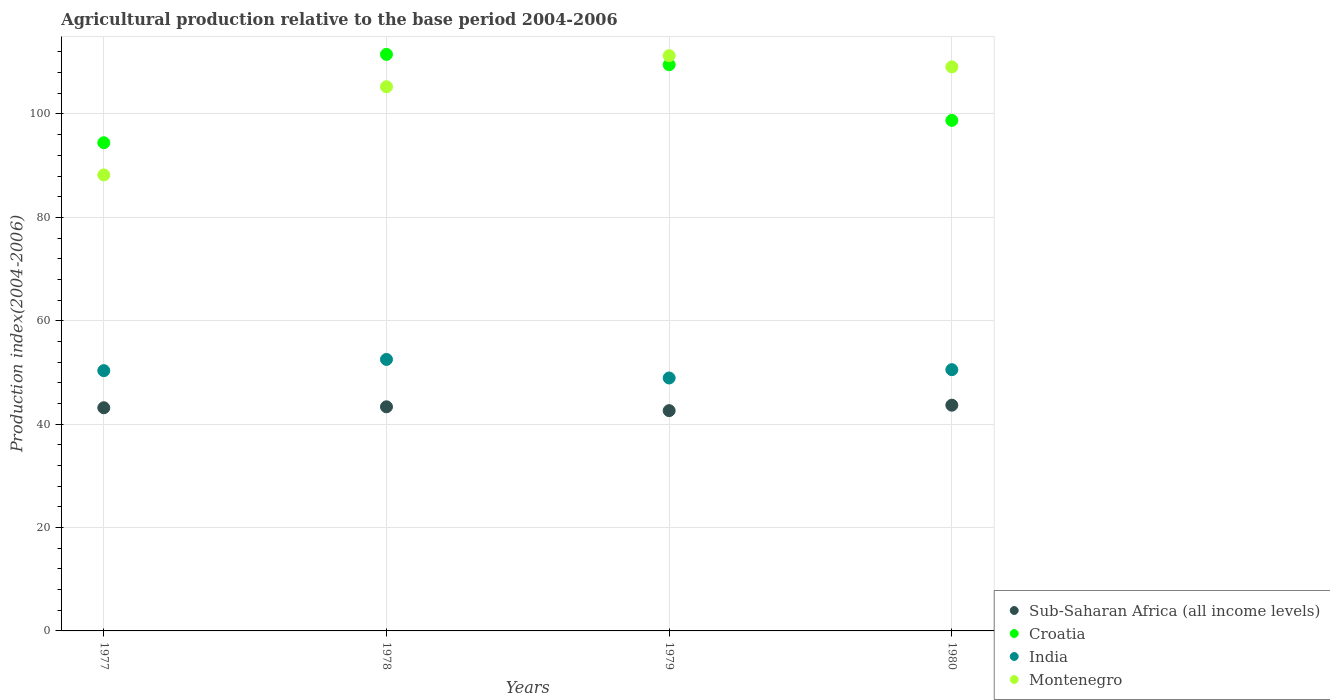How many different coloured dotlines are there?
Your answer should be compact. 4. Is the number of dotlines equal to the number of legend labels?
Provide a succinct answer. Yes. What is the agricultural production index in Sub-Saharan Africa (all income levels) in 1980?
Your response must be concise. 43.67. Across all years, what is the maximum agricultural production index in Croatia?
Offer a very short reply. 111.53. Across all years, what is the minimum agricultural production index in Montenegro?
Provide a short and direct response. 88.21. In which year was the agricultural production index in Montenegro maximum?
Your response must be concise. 1979. In which year was the agricultural production index in Montenegro minimum?
Your answer should be compact. 1977. What is the total agricultural production index in Sub-Saharan Africa (all income levels) in the graph?
Your response must be concise. 172.81. What is the difference between the agricultural production index in India in 1977 and that in 1979?
Keep it short and to the point. 1.42. What is the difference between the agricultural production index in India in 1979 and the agricultural production index in Sub-Saharan Africa (all income levels) in 1977?
Give a very brief answer. 5.76. What is the average agricultural production index in India per year?
Ensure brevity in your answer.  50.59. In the year 1978, what is the difference between the agricultural production index in Croatia and agricultural production index in India?
Offer a very short reply. 59.01. In how many years, is the agricultural production index in Sub-Saharan Africa (all income levels) greater than 48?
Provide a succinct answer. 0. What is the ratio of the agricultural production index in Montenegro in 1978 to that in 1980?
Your response must be concise. 0.96. What is the difference between the highest and the second highest agricultural production index in India?
Give a very brief answer. 1.98. What is the difference between the highest and the lowest agricultural production index in Montenegro?
Your answer should be compact. 23.07. Is it the case that in every year, the sum of the agricultural production index in Sub-Saharan Africa (all income levels) and agricultural production index in Croatia  is greater than the agricultural production index in India?
Provide a succinct answer. Yes. Is the agricultural production index in Montenegro strictly greater than the agricultural production index in India over the years?
Your response must be concise. Yes. How many dotlines are there?
Provide a succinct answer. 4. How many years are there in the graph?
Provide a succinct answer. 4. What is the difference between two consecutive major ticks on the Y-axis?
Your answer should be compact. 20. Where does the legend appear in the graph?
Provide a succinct answer. Bottom right. What is the title of the graph?
Provide a short and direct response. Agricultural production relative to the base period 2004-2006. What is the label or title of the X-axis?
Provide a succinct answer. Years. What is the label or title of the Y-axis?
Your answer should be compact. Production index(2004-2006). What is the Production index(2004-2006) of Sub-Saharan Africa (all income levels) in 1977?
Keep it short and to the point. 43.17. What is the Production index(2004-2006) of Croatia in 1977?
Ensure brevity in your answer.  94.44. What is the Production index(2004-2006) of India in 1977?
Offer a terse response. 50.35. What is the Production index(2004-2006) of Montenegro in 1977?
Offer a very short reply. 88.21. What is the Production index(2004-2006) of Sub-Saharan Africa (all income levels) in 1978?
Provide a short and direct response. 43.36. What is the Production index(2004-2006) of Croatia in 1978?
Keep it short and to the point. 111.53. What is the Production index(2004-2006) in India in 1978?
Provide a short and direct response. 52.52. What is the Production index(2004-2006) in Montenegro in 1978?
Your answer should be compact. 105.27. What is the Production index(2004-2006) of Sub-Saharan Africa (all income levels) in 1979?
Ensure brevity in your answer.  42.61. What is the Production index(2004-2006) of Croatia in 1979?
Keep it short and to the point. 109.53. What is the Production index(2004-2006) of India in 1979?
Provide a succinct answer. 48.93. What is the Production index(2004-2006) in Montenegro in 1979?
Your response must be concise. 111.28. What is the Production index(2004-2006) of Sub-Saharan Africa (all income levels) in 1980?
Ensure brevity in your answer.  43.67. What is the Production index(2004-2006) in Croatia in 1980?
Offer a terse response. 98.76. What is the Production index(2004-2006) of India in 1980?
Make the answer very short. 50.54. What is the Production index(2004-2006) in Montenegro in 1980?
Your response must be concise. 109.11. Across all years, what is the maximum Production index(2004-2006) of Sub-Saharan Africa (all income levels)?
Make the answer very short. 43.67. Across all years, what is the maximum Production index(2004-2006) of Croatia?
Give a very brief answer. 111.53. Across all years, what is the maximum Production index(2004-2006) in India?
Ensure brevity in your answer.  52.52. Across all years, what is the maximum Production index(2004-2006) of Montenegro?
Ensure brevity in your answer.  111.28. Across all years, what is the minimum Production index(2004-2006) of Sub-Saharan Africa (all income levels)?
Give a very brief answer. 42.61. Across all years, what is the minimum Production index(2004-2006) of Croatia?
Keep it short and to the point. 94.44. Across all years, what is the minimum Production index(2004-2006) of India?
Provide a succinct answer. 48.93. Across all years, what is the minimum Production index(2004-2006) of Montenegro?
Your response must be concise. 88.21. What is the total Production index(2004-2006) of Sub-Saharan Africa (all income levels) in the graph?
Your answer should be very brief. 172.81. What is the total Production index(2004-2006) in Croatia in the graph?
Keep it short and to the point. 414.26. What is the total Production index(2004-2006) in India in the graph?
Offer a very short reply. 202.34. What is the total Production index(2004-2006) of Montenegro in the graph?
Offer a terse response. 413.87. What is the difference between the Production index(2004-2006) in Sub-Saharan Africa (all income levels) in 1977 and that in 1978?
Offer a terse response. -0.18. What is the difference between the Production index(2004-2006) of Croatia in 1977 and that in 1978?
Ensure brevity in your answer.  -17.09. What is the difference between the Production index(2004-2006) in India in 1977 and that in 1978?
Offer a very short reply. -2.17. What is the difference between the Production index(2004-2006) of Montenegro in 1977 and that in 1978?
Provide a succinct answer. -17.06. What is the difference between the Production index(2004-2006) of Sub-Saharan Africa (all income levels) in 1977 and that in 1979?
Keep it short and to the point. 0.56. What is the difference between the Production index(2004-2006) in Croatia in 1977 and that in 1979?
Provide a short and direct response. -15.09. What is the difference between the Production index(2004-2006) in India in 1977 and that in 1979?
Your response must be concise. 1.42. What is the difference between the Production index(2004-2006) in Montenegro in 1977 and that in 1979?
Provide a short and direct response. -23.07. What is the difference between the Production index(2004-2006) in Sub-Saharan Africa (all income levels) in 1977 and that in 1980?
Your response must be concise. -0.49. What is the difference between the Production index(2004-2006) of Croatia in 1977 and that in 1980?
Your answer should be compact. -4.32. What is the difference between the Production index(2004-2006) of India in 1977 and that in 1980?
Provide a short and direct response. -0.19. What is the difference between the Production index(2004-2006) of Montenegro in 1977 and that in 1980?
Keep it short and to the point. -20.9. What is the difference between the Production index(2004-2006) of Sub-Saharan Africa (all income levels) in 1978 and that in 1979?
Your answer should be compact. 0.74. What is the difference between the Production index(2004-2006) in Croatia in 1978 and that in 1979?
Provide a short and direct response. 2. What is the difference between the Production index(2004-2006) in India in 1978 and that in 1979?
Give a very brief answer. 3.59. What is the difference between the Production index(2004-2006) of Montenegro in 1978 and that in 1979?
Offer a terse response. -6.01. What is the difference between the Production index(2004-2006) of Sub-Saharan Africa (all income levels) in 1978 and that in 1980?
Keep it short and to the point. -0.31. What is the difference between the Production index(2004-2006) of Croatia in 1978 and that in 1980?
Provide a short and direct response. 12.77. What is the difference between the Production index(2004-2006) in India in 1978 and that in 1980?
Your answer should be very brief. 1.98. What is the difference between the Production index(2004-2006) of Montenegro in 1978 and that in 1980?
Offer a terse response. -3.84. What is the difference between the Production index(2004-2006) in Sub-Saharan Africa (all income levels) in 1979 and that in 1980?
Keep it short and to the point. -1.05. What is the difference between the Production index(2004-2006) in Croatia in 1979 and that in 1980?
Keep it short and to the point. 10.77. What is the difference between the Production index(2004-2006) of India in 1979 and that in 1980?
Offer a terse response. -1.61. What is the difference between the Production index(2004-2006) in Montenegro in 1979 and that in 1980?
Give a very brief answer. 2.17. What is the difference between the Production index(2004-2006) in Sub-Saharan Africa (all income levels) in 1977 and the Production index(2004-2006) in Croatia in 1978?
Your response must be concise. -68.36. What is the difference between the Production index(2004-2006) in Sub-Saharan Africa (all income levels) in 1977 and the Production index(2004-2006) in India in 1978?
Ensure brevity in your answer.  -9.35. What is the difference between the Production index(2004-2006) in Sub-Saharan Africa (all income levels) in 1977 and the Production index(2004-2006) in Montenegro in 1978?
Your answer should be very brief. -62.1. What is the difference between the Production index(2004-2006) of Croatia in 1977 and the Production index(2004-2006) of India in 1978?
Offer a very short reply. 41.92. What is the difference between the Production index(2004-2006) of Croatia in 1977 and the Production index(2004-2006) of Montenegro in 1978?
Make the answer very short. -10.83. What is the difference between the Production index(2004-2006) of India in 1977 and the Production index(2004-2006) of Montenegro in 1978?
Offer a very short reply. -54.92. What is the difference between the Production index(2004-2006) in Sub-Saharan Africa (all income levels) in 1977 and the Production index(2004-2006) in Croatia in 1979?
Your answer should be very brief. -66.36. What is the difference between the Production index(2004-2006) of Sub-Saharan Africa (all income levels) in 1977 and the Production index(2004-2006) of India in 1979?
Provide a short and direct response. -5.76. What is the difference between the Production index(2004-2006) in Sub-Saharan Africa (all income levels) in 1977 and the Production index(2004-2006) in Montenegro in 1979?
Ensure brevity in your answer.  -68.11. What is the difference between the Production index(2004-2006) of Croatia in 1977 and the Production index(2004-2006) of India in 1979?
Provide a short and direct response. 45.51. What is the difference between the Production index(2004-2006) of Croatia in 1977 and the Production index(2004-2006) of Montenegro in 1979?
Your response must be concise. -16.84. What is the difference between the Production index(2004-2006) in India in 1977 and the Production index(2004-2006) in Montenegro in 1979?
Provide a succinct answer. -60.93. What is the difference between the Production index(2004-2006) in Sub-Saharan Africa (all income levels) in 1977 and the Production index(2004-2006) in Croatia in 1980?
Your answer should be very brief. -55.59. What is the difference between the Production index(2004-2006) in Sub-Saharan Africa (all income levels) in 1977 and the Production index(2004-2006) in India in 1980?
Keep it short and to the point. -7.37. What is the difference between the Production index(2004-2006) of Sub-Saharan Africa (all income levels) in 1977 and the Production index(2004-2006) of Montenegro in 1980?
Provide a succinct answer. -65.94. What is the difference between the Production index(2004-2006) in Croatia in 1977 and the Production index(2004-2006) in India in 1980?
Provide a short and direct response. 43.9. What is the difference between the Production index(2004-2006) of Croatia in 1977 and the Production index(2004-2006) of Montenegro in 1980?
Keep it short and to the point. -14.67. What is the difference between the Production index(2004-2006) in India in 1977 and the Production index(2004-2006) in Montenegro in 1980?
Your response must be concise. -58.76. What is the difference between the Production index(2004-2006) of Sub-Saharan Africa (all income levels) in 1978 and the Production index(2004-2006) of Croatia in 1979?
Provide a succinct answer. -66.17. What is the difference between the Production index(2004-2006) in Sub-Saharan Africa (all income levels) in 1978 and the Production index(2004-2006) in India in 1979?
Keep it short and to the point. -5.57. What is the difference between the Production index(2004-2006) of Sub-Saharan Africa (all income levels) in 1978 and the Production index(2004-2006) of Montenegro in 1979?
Make the answer very short. -67.92. What is the difference between the Production index(2004-2006) in Croatia in 1978 and the Production index(2004-2006) in India in 1979?
Provide a succinct answer. 62.6. What is the difference between the Production index(2004-2006) in Croatia in 1978 and the Production index(2004-2006) in Montenegro in 1979?
Your response must be concise. 0.25. What is the difference between the Production index(2004-2006) in India in 1978 and the Production index(2004-2006) in Montenegro in 1979?
Keep it short and to the point. -58.76. What is the difference between the Production index(2004-2006) of Sub-Saharan Africa (all income levels) in 1978 and the Production index(2004-2006) of Croatia in 1980?
Give a very brief answer. -55.4. What is the difference between the Production index(2004-2006) of Sub-Saharan Africa (all income levels) in 1978 and the Production index(2004-2006) of India in 1980?
Ensure brevity in your answer.  -7.18. What is the difference between the Production index(2004-2006) in Sub-Saharan Africa (all income levels) in 1978 and the Production index(2004-2006) in Montenegro in 1980?
Your answer should be very brief. -65.75. What is the difference between the Production index(2004-2006) in Croatia in 1978 and the Production index(2004-2006) in India in 1980?
Give a very brief answer. 60.99. What is the difference between the Production index(2004-2006) in Croatia in 1978 and the Production index(2004-2006) in Montenegro in 1980?
Your answer should be very brief. 2.42. What is the difference between the Production index(2004-2006) in India in 1978 and the Production index(2004-2006) in Montenegro in 1980?
Your response must be concise. -56.59. What is the difference between the Production index(2004-2006) of Sub-Saharan Africa (all income levels) in 1979 and the Production index(2004-2006) of Croatia in 1980?
Offer a very short reply. -56.15. What is the difference between the Production index(2004-2006) in Sub-Saharan Africa (all income levels) in 1979 and the Production index(2004-2006) in India in 1980?
Give a very brief answer. -7.93. What is the difference between the Production index(2004-2006) in Sub-Saharan Africa (all income levels) in 1979 and the Production index(2004-2006) in Montenegro in 1980?
Your answer should be compact. -66.5. What is the difference between the Production index(2004-2006) of Croatia in 1979 and the Production index(2004-2006) of India in 1980?
Your answer should be compact. 58.99. What is the difference between the Production index(2004-2006) in Croatia in 1979 and the Production index(2004-2006) in Montenegro in 1980?
Give a very brief answer. 0.42. What is the difference between the Production index(2004-2006) of India in 1979 and the Production index(2004-2006) of Montenegro in 1980?
Ensure brevity in your answer.  -60.18. What is the average Production index(2004-2006) in Sub-Saharan Africa (all income levels) per year?
Make the answer very short. 43.2. What is the average Production index(2004-2006) in Croatia per year?
Your answer should be compact. 103.56. What is the average Production index(2004-2006) of India per year?
Your response must be concise. 50.59. What is the average Production index(2004-2006) of Montenegro per year?
Your answer should be compact. 103.47. In the year 1977, what is the difference between the Production index(2004-2006) in Sub-Saharan Africa (all income levels) and Production index(2004-2006) in Croatia?
Make the answer very short. -51.27. In the year 1977, what is the difference between the Production index(2004-2006) of Sub-Saharan Africa (all income levels) and Production index(2004-2006) of India?
Your answer should be compact. -7.18. In the year 1977, what is the difference between the Production index(2004-2006) of Sub-Saharan Africa (all income levels) and Production index(2004-2006) of Montenegro?
Offer a terse response. -45.04. In the year 1977, what is the difference between the Production index(2004-2006) of Croatia and Production index(2004-2006) of India?
Provide a succinct answer. 44.09. In the year 1977, what is the difference between the Production index(2004-2006) of Croatia and Production index(2004-2006) of Montenegro?
Your answer should be very brief. 6.23. In the year 1977, what is the difference between the Production index(2004-2006) of India and Production index(2004-2006) of Montenegro?
Your answer should be compact. -37.86. In the year 1978, what is the difference between the Production index(2004-2006) in Sub-Saharan Africa (all income levels) and Production index(2004-2006) in Croatia?
Offer a very short reply. -68.17. In the year 1978, what is the difference between the Production index(2004-2006) in Sub-Saharan Africa (all income levels) and Production index(2004-2006) in India?
Give a very brief answer. -9.16. In the year 1978, what is the difference between the Production index(2004-2006) in Sub-Saharan Africa (all income levels) and Production index(2004-2006) in Montenegro?
Ensure brevity in your answer.  -61.91. In the year 1978, what is the difference between the Production index(2004-2006) in Croatia and Production index(2004-2006) in India?
Keep it short and to the point. 59.01. In the year 1978, what is the difference between the Production index(2004-2006) in Croatia and Production index(2004-2006) in Montenegro?
Your answer should be very brief. 6.26. In the year 1978, what is the difference between the Production index(2004-2006) in India and Production index(2004-2006) in Montenegro?
Offer a terse response. -52.75. In the year 1979, what is the difference between the Production index(2004-2006) in Sub-Saharan Africa (all income levels) and Production index(2004-2006) in Croatia?
Provide a short and direct response. -66.92. In the year 1979, what is the difference between the Production index(2004-2006) in Sub-Saharan Africa (all income levels) and Production index(2004-2006) in India?
Provide a succinct answer. -6.32. In the year 1979, what is the difference between the Production index(2004-2006) in Sub-Saharan Africa (all income levels) and Production index(2004-2006) in Montenegro?
Offer a very short reply. -68.67. In the year 1979, what is the difference between the Production index(2004-2006) in Croatia and Production index(2004-2006) in India?
Offer a very short reply. 60.6. In the year 1979, what is the difference between the Production index(2004-2006) of Croatia and Production index(2004-2006) of Montenegro?
Ensure brevity in your answer.  -1.75. In the year 1979, what is the difference between the Production index(2004-2006) of India and Production index(2004-2006) of Montenegro?
Provide a succinct answer. -62.35. In the year 1980, what is the difference between the Production index(2004-2006) in Sub-Saharan Africa (all income levels) and Production index(2004-2006) in Croatia?
Offer a terse response. -55.09. In the year 1980, what is the difference between the Production index(2004-2006) in Sub-Saharan Africa (all income levels) and Production index(2004-2006) in India?
Offer a very short reply. -6.87. In the year 1980, what is the difference between the Production index(2004-2006) in Sub-Saharan Africa (all income levels) and Production index(2004-2006) in Montenegro?
Offer a terse response. -65.44. In the year 1980, what is the difference between the Production index(2004-2006) of Croatia and Production index(2004-2006) of India?
Make the answer very short. 48.22. In the year 1980, what is the difference between the Production index(2004-2006) in Croatia and Production index(2004-2006) in Montenegro?
Give a very brief answer. -10.35. In the year 1980, what is the difference between the Production index(2004-2006) in India and Production index(2004-2006) in Montenegro?
Provide a succinct answer. -58.57. What is the ratio of the Production index(2004-2006) of Sub-Saharan Africa (all income levels) in 1977 to that in 1978?
Ensure brevity in your answer.  1. What is the ratio of the Production index(2004-2006) of Croatia in 1977 to that in 1978?
Keep it short and to the point. 0.85. What is the ratio of the Production index(2004-2006) of India in 1977 to that in 1978?
Offer a very short reply. 0.96. What is the ratio of the Production index(2004-2006) of Montenegro in 1977 to that in 1978?
Make the answer very short. 0.84. What is the ratio of the Production index(2004-2006) in Sub-Saharan Africa (all income levels) in 1977 to that in 1979?
Make the answer very short. 1.01. What is the ratio of the Production index(2004-2006) in Croatia in 1977 to that in 1979?
Give a very brief answer. 0.86. What is the ratio of the Production index(2004-2006) in India in 1977 to that in 1979?
Give a very brief answer. 1.03. What is the ratio of the Production index(2004-2006) of Montenegro in 1977 to that in 1979?
Your answer should be very brief. 0.79. What is the ratio of the Production index(2004-2006) of Sub-Saharan Africa (all income levels) in 1977 to that in 1980?
Give a very brief answer. 0.99. What is the ratio of the Production index(2004-2006) of Croatia in 1977 to that in 1980?
Your response must be concise. 0.96. What is the ratio of the Production index(2004-2006) in Montenegro in 1977 to that in 1980?
Provide a succinct answer. 0.81. What is the ratio of the Production index(2004-2006) in Sub-Saharan Africa (all income levels) in 1978 to that in 1979?
Provide a succinct answer. 1.02. What is the ratio of the Production index(2004-2006) in Croatia in 1978 to that in 1979?
Offer a very short reply. 1.02. What is the ratio of the Production index(2004-2006) in India in 1978 to that in 1979?
Offer a very short reply. 1.07. What is the ratio of the Production index(2004-2006) in Montenegro in 1978 to that in 1979?
Ensure brevity in your answer.  0.95. What is the ratio of the Production index(2004-2006) of Sub-Saharan Africa (all income levels) in 1978 to that in 1980?
Offer a terse response. 0.99. What is the ratio of the Production index(2004-2006) in Croatia in 1978 to that in 1980?
Your answer should be compact. 1.13. What is the ratio of the Production index(2004-2006) of India in 1978 to that in 1980?
Your answer should be compact. 1.04. What is the ratio of the Production index(2004-2006) of Montenegro in 1978 to that in 1980?
Your response must be concise. 0.96. What is the ratio of the Production index(2004-2006) in Sub-Saharan Africa (all income levels) in 1979 to that in 1980?
Your answer should be compact. 0.98. What is the ratio of the Production index(2004-2006) in Croatia in 1979 to that in 1980?
Your answer should be very brief. 1.11. What is the ratio of the Production index(2004-2006) of India in 1979 to that in 1980?
Offer a terse response. 0.97. What is the ratio of the Production index(2004-2006) of Montenegro in 1979 to that in 1980?
Ensure brevity in your answer.  1.02. What is the difference between the highest and the second highest Production index(2004-2006) in Sub-Saharan Africa (all income levels)?
Provide a succinct answer. 0.31. What is the difference between the highest and the second highest Production index(2004-2006) of Croatia?
Offer a very short reply. 2. What is the difference between the highest and the second highest Production index(2004-2006) of India?
Provide a short and direct response. 1.98. What is the difference between the highest and the second highest Production index(2004-2006) of Montenegro?
Provide a short and direct response. 2.17. What is the difference between the highest and the lowest Production index(2004-2006) in Sub-Saharan Africa (all income levels)?
Offer a very short reply. 1.05. What is the difference between the highest and the lowest Production index(2004-2006) in Croatia?
Make the answer very short. 17.09. What is the difference between the highest and the lowest Production index(2004-2006) in India?
Ensure brevity in your answer.  3.59. What is the difference between the highest and the lowest Production index(2004-2006) of Montenegro?
Offer a very short reply. 23.07. 